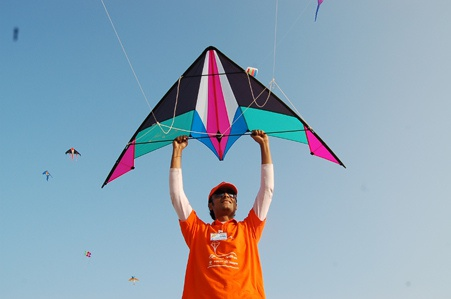Describe the objects in this image and their specific colors. I can see kite in gray, black, teal, magenta, and purple tones, people in gray, red, brown, and maroon tones, kite in gray, blue, darkgray, lightblue, and purple tones, kite in gray, black, and maroon tones, and kite in gray, darkgray, tan, and lightblue tones in this image. 